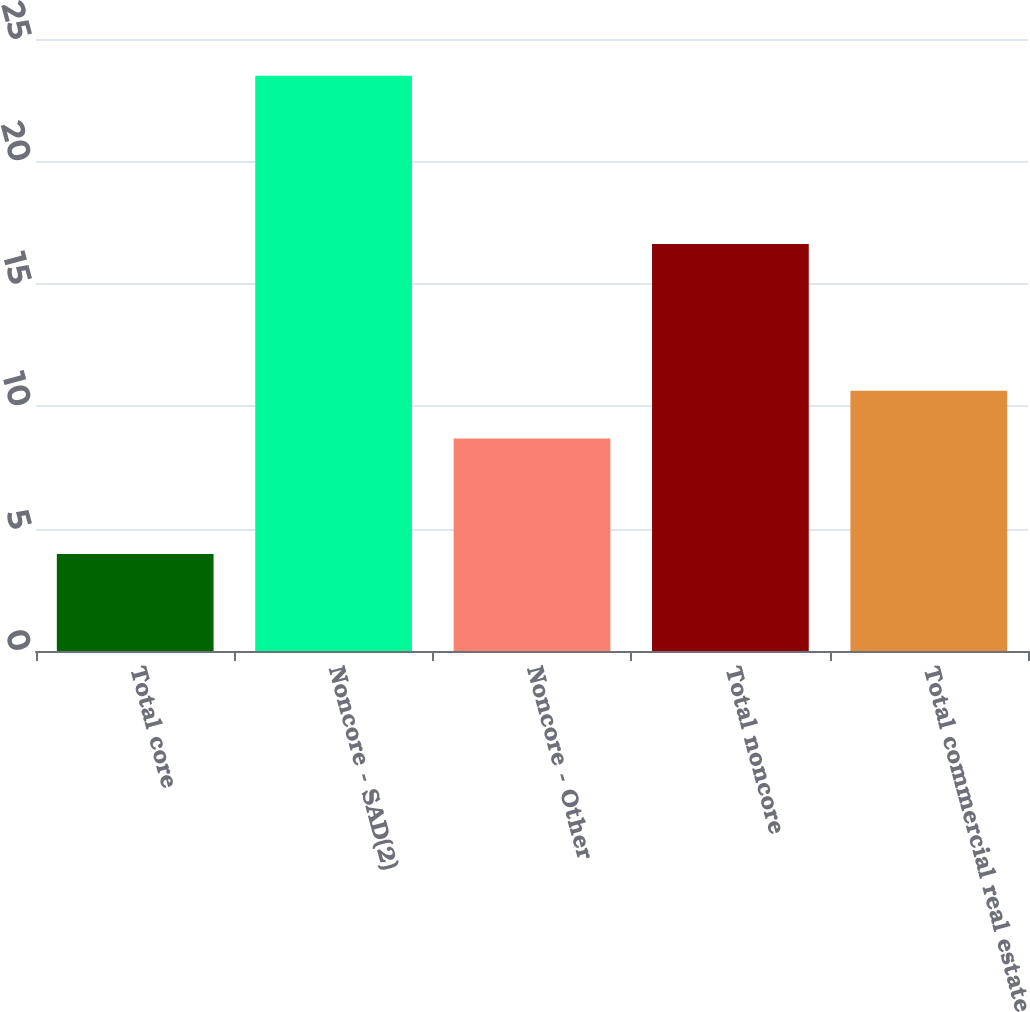Convert chart. <chart><loc_0><loc_0><loc_500><loc_500><bar_chart><fcel>Total core<fcel>Noncore - SAD(2)<fcel>Noncore - Other<fcel>Total noncore<fcel>Total commercial real estate<nl><fcel>3.96<fcel>23.5<fcel>8.68<fcel>16.63<fcel>10.63<nl></chart> 